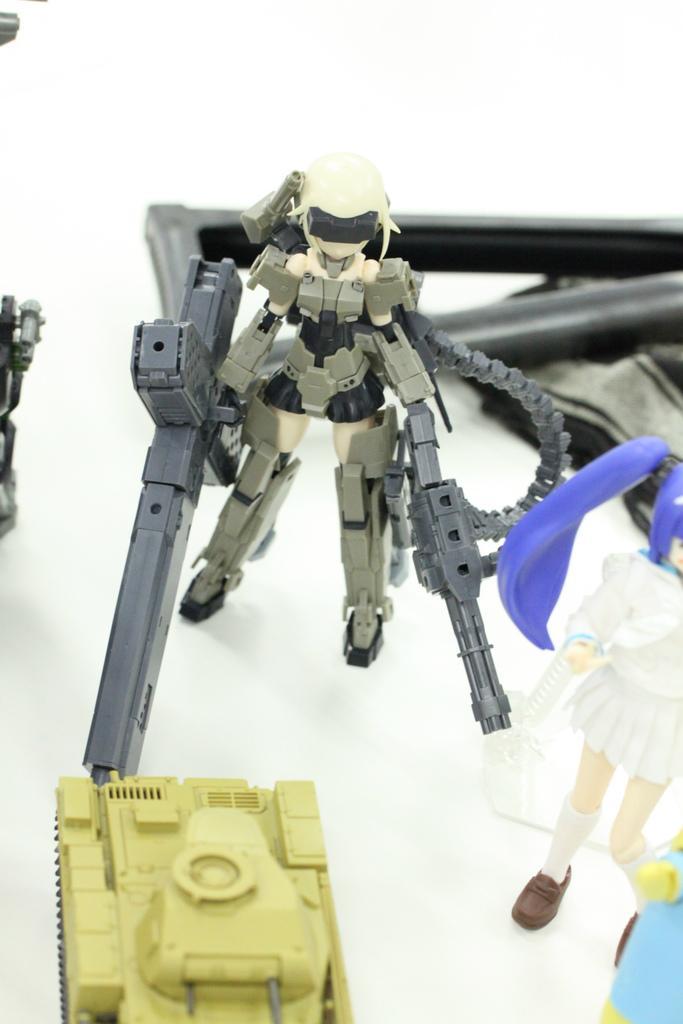Could you give a brief overview of what you see in this image? As we can see in the image there is a table. On table there are few toys. 